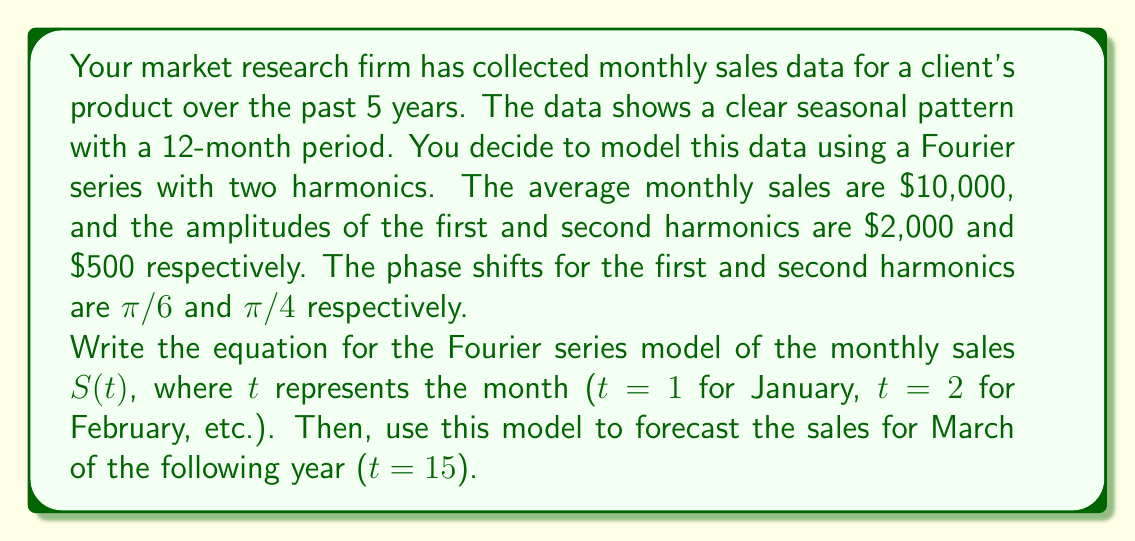Solve this math problem. Let's approach this step-by-step:

1) The general form of a Fourier series with two harmonics for monthly data is:

   $$S(t) = A_0 + A_1 \cos(\frac{2\pi t}{12} - \phi_1) + A_2 \cos(\frac{4\pi t}{12} - \phi_2)$$

   Where:
   $A_0$ is the average value
   $A_1$ and $A_2$ are the amplitudes of the first and second harmonics
   $\phi_1$ and $\phi_2$ are the phase shifts of the first and second harmonics

2) We're given:
   $A_0 = 10000$
   $A_1 = 2000$
   $A_2 = 500$
   $\phi_1 = \pi/6$
   $\phi_2 = \pi/4$

3) Substituting these values into the general equation:

   $$S(t) = 10000 + 2000 \cos(\frac{2\pi t}{12} - \frac{\pi}{6}) + 500 \cos(\frac{4\pi t}{12} - \frac{\pi}{4})$$

4) To forecast sales for March of the following year, we need to set t = 15 (12 months + 3 for March):

   $$S(15) = 10000 + 2000 \cos(\frac{2\pi (15)}{12} - \frac{\pi}{6}) + 500 \cos(\frac{4\pi (15)}{12} - \frac{\pi}{4})$$

5) Simplify the arguments of the cosine functions:

   $$S(15) = 10000 + 2000 \cos(\frac{5\pi}{2} - \frac{\pi}{6}) + 500 \cos(5\pi - \frac{\pi}{4})$$

6) Calculate:
   $\frac{5\pi}{2} - \frac{\pi}{6} = \frac{14\pi}{6}$
   $5\pi - \frac{\pi}{4} = \frac{19\pi}{4}$

7) Substitute:

   $$S(15) = 10000 + 2000 \cos(\frac{14\pi}{6}) + 500 \cos(\frac{19\pi}{4})$$

8) Calculate:
   $\cos(\frac{14\pi}{6}) = \cos(\frac{7\pi}{3}) = \frac{\sqrt{3}}{2}$
   $\cos(\frac{19\pi}{4}) = -\frac{\sqrt{2}}{2}$

9) Final calculation:

   $$S(15) = 10000 + 2000 (\frac{\sqrt{3}}{2}) + 500 (-\frac{\sqrt{2}}{2})$$
   $$S(15) = 10000 + 1000\sqrt{3} - 250\sqrt{2}$$
   $$S(15) = 11732.05$$ (rounded to two decimal places)
Answer: The Fourier series model for monthly sales is:

$$S(t) = 10000 + 2000 \cos(\frac{2\pi t}{12} - \frac{\pi}{6}) + 500 \cos(\frac{4\pi t}{12} - \frac{\pi}{4})$$

The forecasted sales for March of the following year (t = 15) is $11,732.05. 